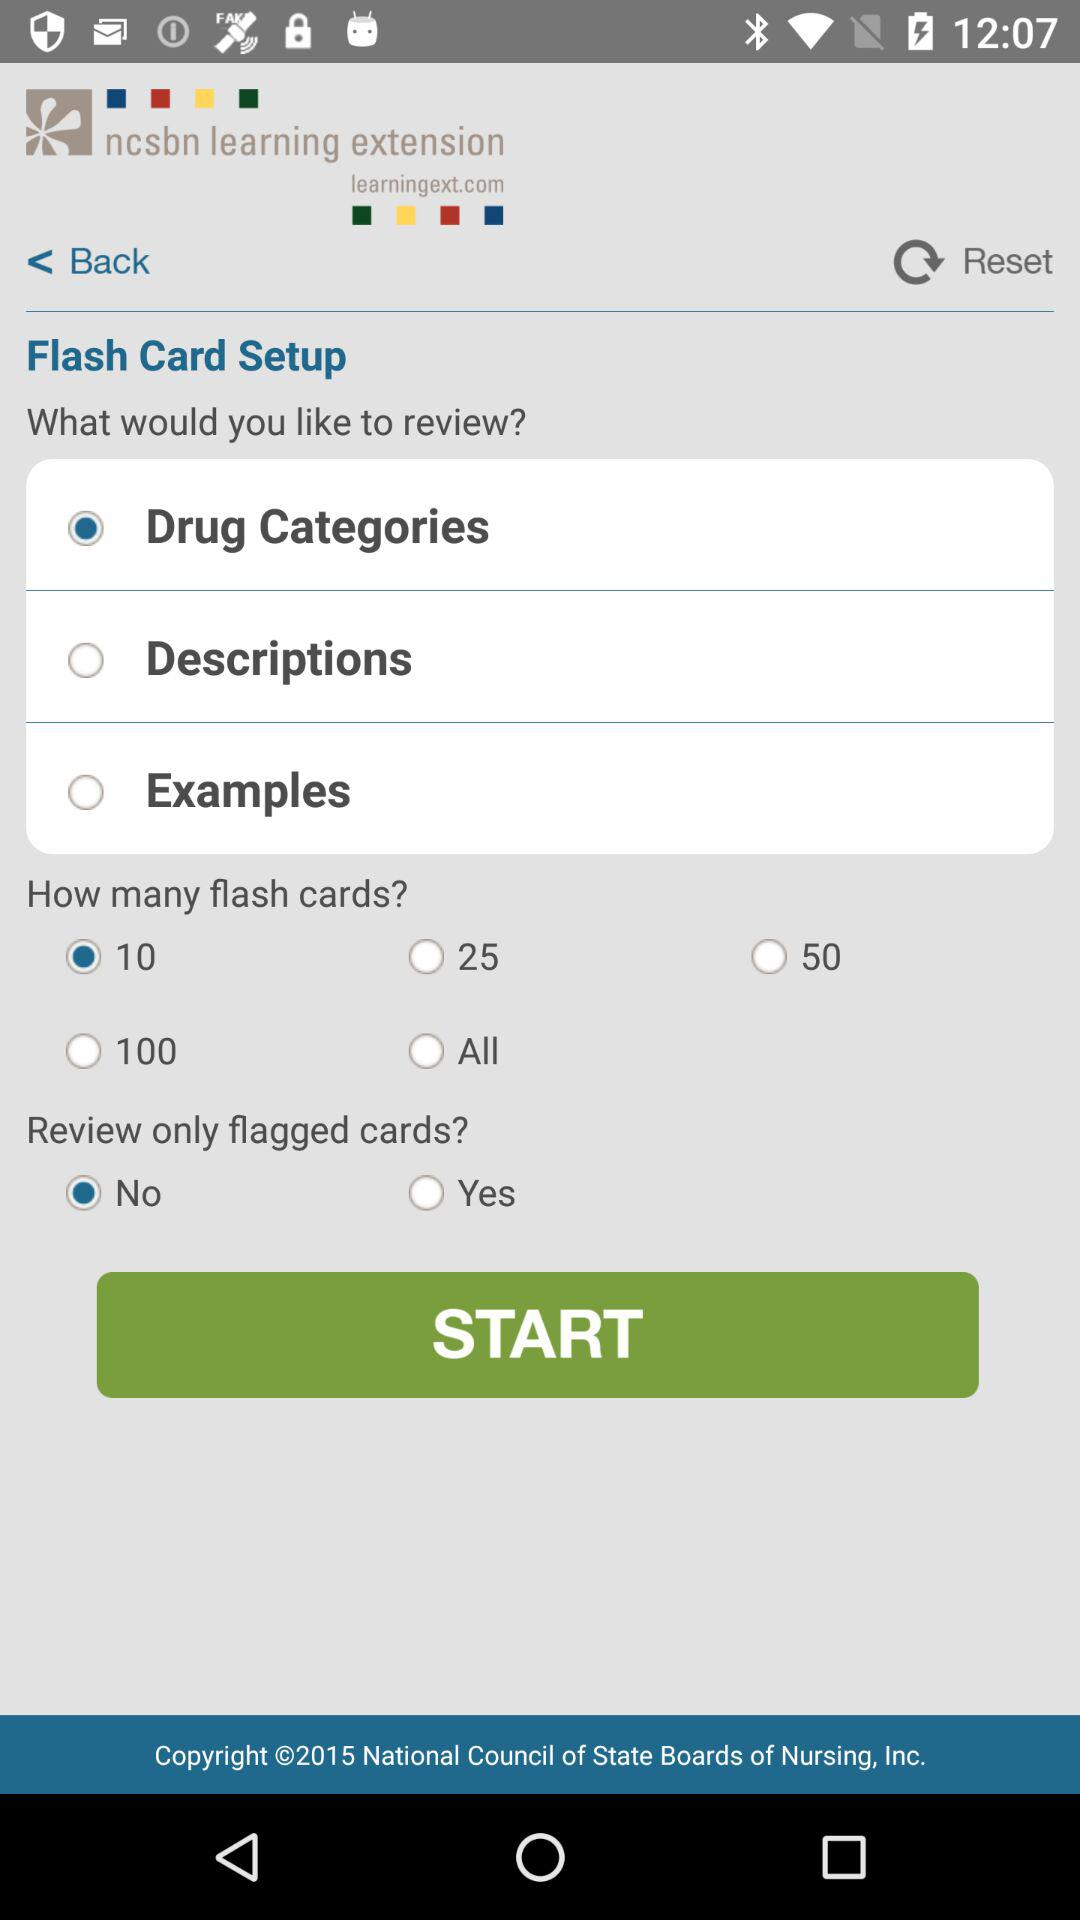What are the selected options? The selected options are "Drug Categories", "10", and "No". 